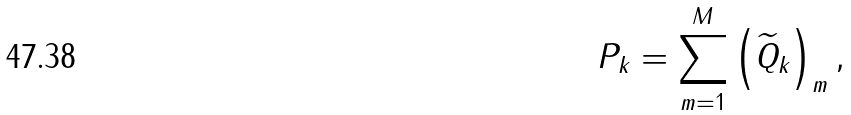Convert formula to latex. <formula><loc_0><loc_0><loc_500><loc_500>P _ { k } = \sum _ { m = 1 } ^ { M } \left ( \widetilde { Q } _ { k } \right ) _ { m } ,</formula> 